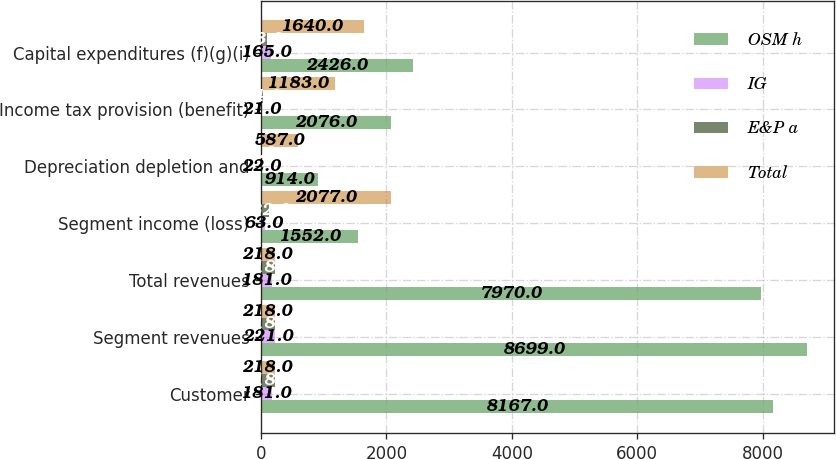<chart> <loc_0><loc_0><loc_500><loc_500><stacked_bar_chart><ecel><fcel>Customer<fcel>Segment revenues<fcel>Total revenues<fcel>Segment income (loss)<fcel>Depreciation depletion and<fcel>Income tax provision (benefit)<fcel>Capital expenditures (f)(g)(i)<nl><fcel>OSM h<fcel>8167<fcel>8699<fcel>7970<fcel>1552<fcel>914<fcel>2076<fcel>2426<nl><fcel>IG<fcel>181<fcel>221<fcel>181<fcel>63<fcel>22<fcel>21<fcel>165<nl><fcel>E&P a<fcel>218<fcel>218<fcel>218<fcel>132<fcel>6<fcel>24<fcel>93<nl><fcel>Total<fcel>218<fcel>218<fcel>218<fcel>2077<fcel>587<fcel>1183<fcel>1640<nl></chart> 